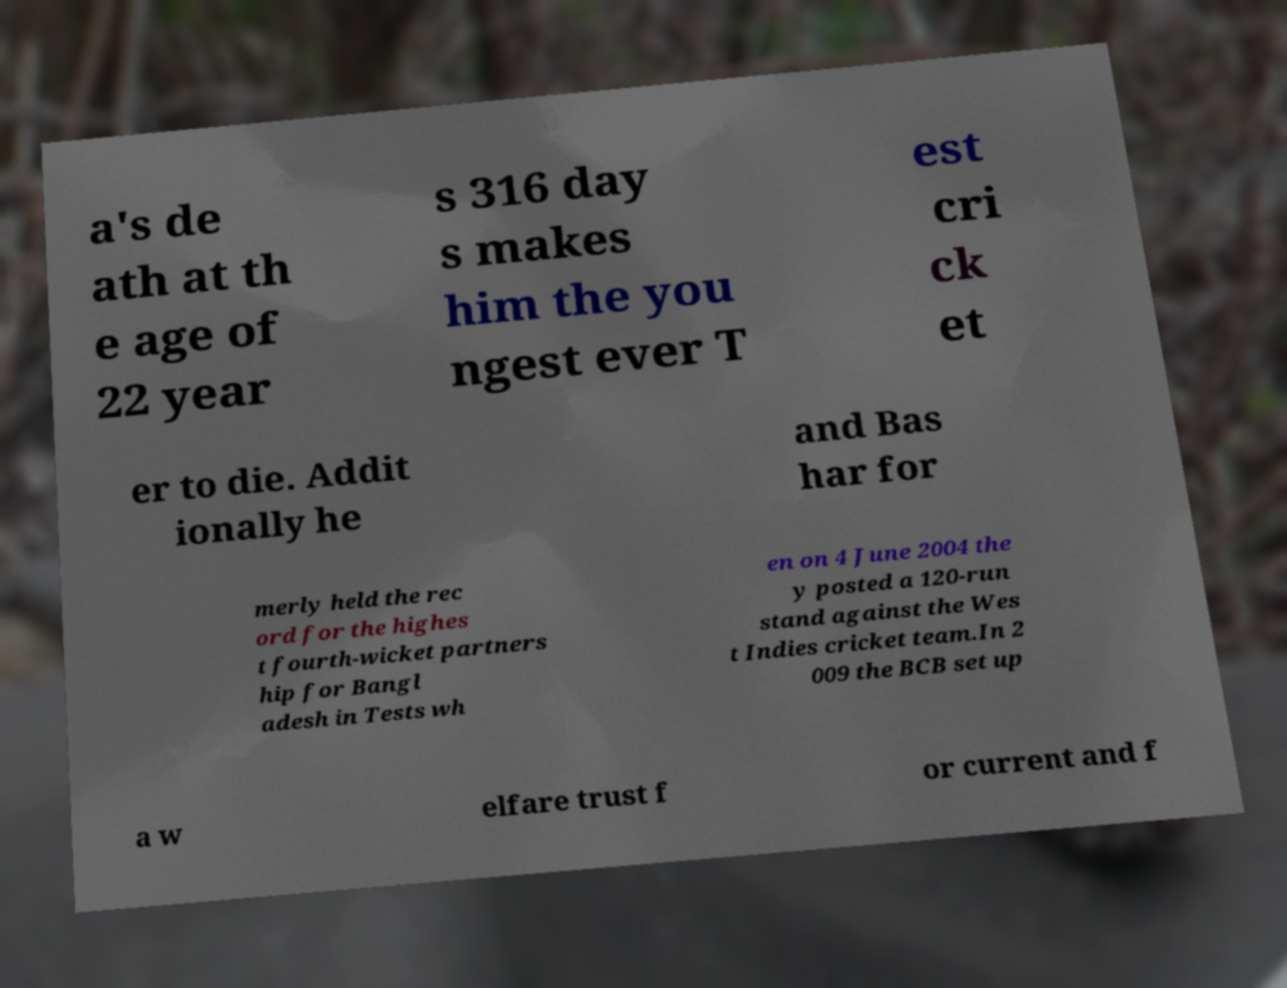I need the written content from this picture converted into text. Can you do that? a's de ath at th e age of 22 year s 316 day s makes him the you ngest ever T est cri ck et er to die. Addit ionally he and Bas har for merly held the rec ord for the highes t fourth-wicket partners hip for Bangl adesh in Tests wh en on 4 June 2004 the y posted a 120-run stand against the Wes t Indies cricket team.In 2 009 the BCB set up a w elfare trust f or current and f 